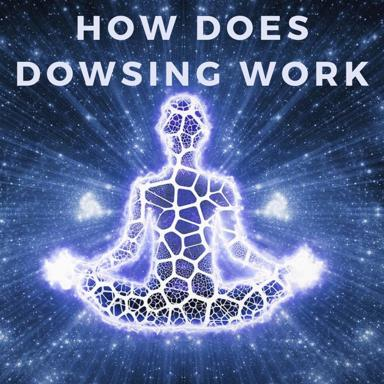What is dowsing? Dowsing, also known as divining, is an age-old practice where practitioners use tools such as a forked rod, pendulum, or wire to locate underground water, minerals, or other hidden objects. Historically, dowsers believe this ability stems from a supernatural sense or a special sensitivity to Earth's magnetic fields. Despite its popularity, the scientific community remains skeptical about the efficacy of dowsing, attributing successful finds often to coincidence. 